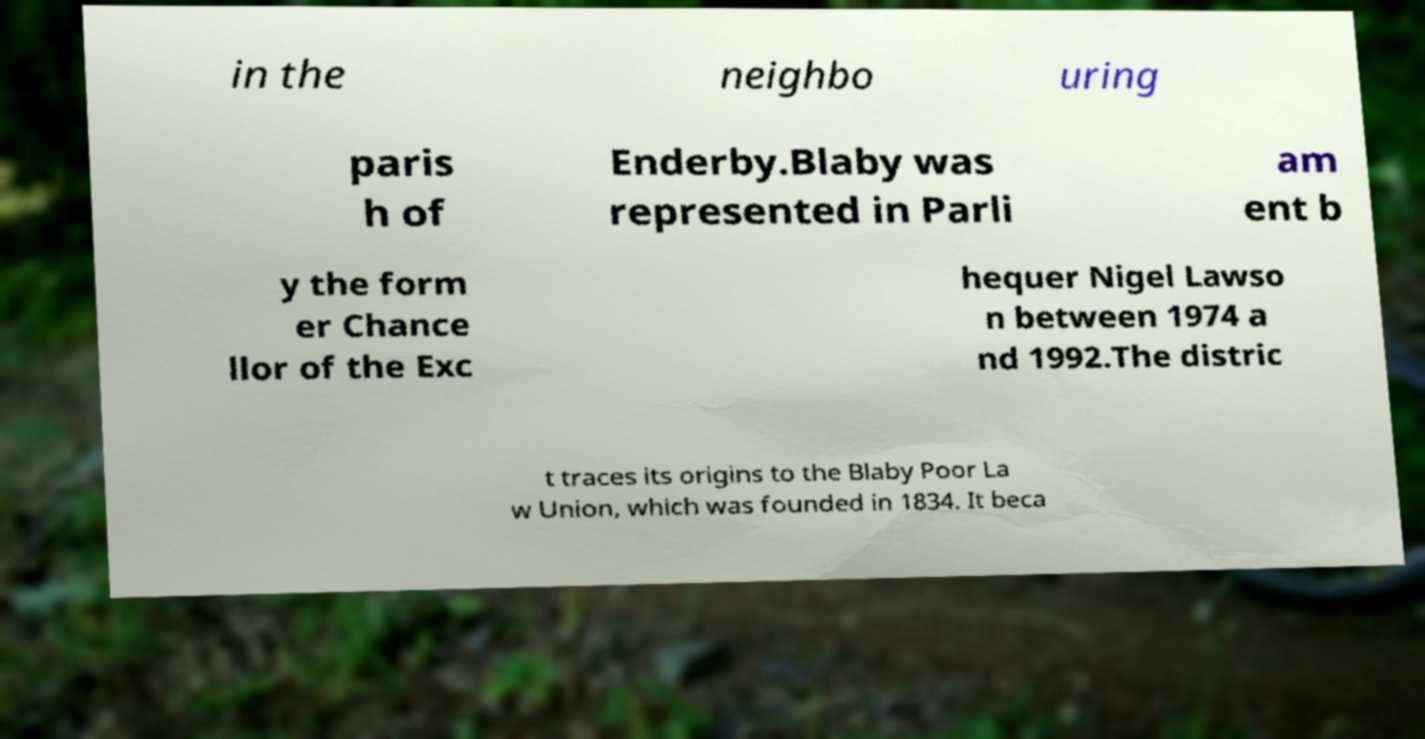Please identify and transcribe the text found in this image. in the neighbo uring paris h of Enderby.Blaby was represented in Parli am ent b y the form er Chance llor of the Exc hequer Nigel Lawso n between 1974 a nd 1992.The distric t traces its origins to the Blaby Poor La w Union, which was founded in 1834. It beca 